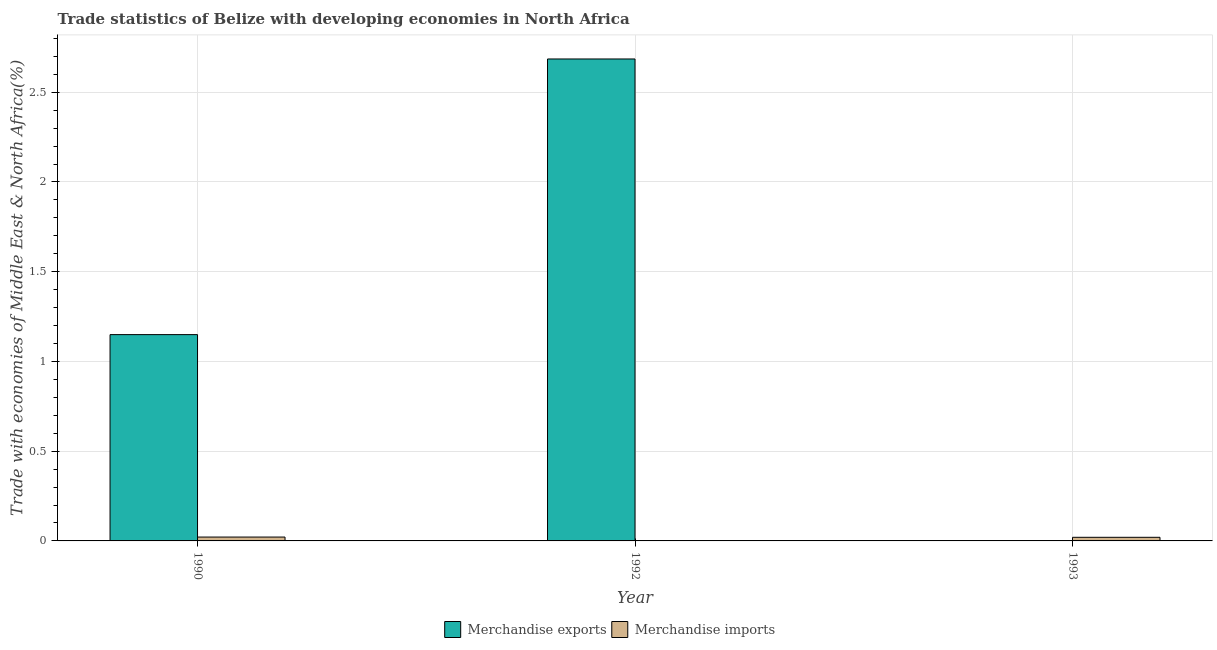How many different coloured bars are there?
Offer a very short reply. 2. How many groups of bars are there?
Offer a very short reply. 3. Are the number of bars per tick equal to the number of legend labels?
Offer a terse response. Yes. Are the number of bars on each tick of the X-axis equal?
Keep it short and to the point. Yes. How many bars are there on the 3rd tick from the right?
Your answer should be very brief. 2. What is the label of the 2nd group of bars from the left?
Your response must be concise. 1992. What is the merchandise exports in 1993?
Offer a terse response. 0. Across all years, what is the maximum merchandise exports?
Offer a terse response. 2.69. Across all years, what is the minimum merchandise imports?
Make the answer very short. 0. In which year was the merchandise imports minimum?
Your answer should be very brief. 1992. What is the total merchandise exports in the graph?
Offer a very short reply. 3.84. What is the difference between the merchandise imports in 1992 and that in 1993?
Ensure brevity in your answer.  -0.02. What is the difference between the merchandise exports in 1992 and the merchandise imports in 1993?
Offer a very short reply. 2.68. What is the average merchandise imports per year?
Make the answer very short. 0.01. In the year 1993, what is the difference between the merchandise exports and merchandise imports?
Your answer should be very brief. 0. What is the ratio of the merchandise exports in 1992 to that in 1993?
Offer a terse response. 7050.16. Is the difference between the merchandise exports in 1990 and 1993 greater than the difference between the merchandise imports in 1990 and 1993?
Your answer should be very brief. No. What is the difference between the highest and the second highest merchandise exports?
Make the answer very short. 1.54. What is the difference between the highest and the lowest merchandise imports?
Keep it short and to the point. 0.02. In how many years, is the merchandise imports greater than the average merchandise imports taken over all years?
Your answer should be very brief. 2. Is the sum of the merchandise exports in 1990 and 1992 greater than the maximum merchandise imports across all years?
Make the answer very short. Yes. How many bars are there?
Offer a terse response. 6. What is the difference between two consecutive major ticks on the Y-axis?
Provide a short and direct response. 0.5. Does the graph contain grids?
Provide a succinct answer. Yes. How many legend labels are there?
Keep it short and to the point. 2. How are the legend labels stacked?
Give a very brief answer. Horizontal. What is the title of the graph?
Your response must be concise. Trade statistics of Belize with developing economies in North Africa. Does "Goods" appear as one of the legend labels in the graph?
Keep it short and to the point. No. What is the label or title of the X-axis?
Provide a succinct answer. Year. What is the label or title of the Y-axis?
Provide a short and direct response. Trade with economies of Middle East & North Africa(%). What is the Trade with economies of Middle East & North Africa(%) in Merchandise exports in 1990?
Ensure brevity in your answer.  1.15. What is the Trade with economies of Middle East & North Africa(%) of Merchandise imports in 1990?
Make the answer very short. 0.02. What is the Trade with economies of Middle East & North Africa(%) in Merchandise exports in 1992?
Your answer should be compact. 2.69. What is the Trade with economies of Middle East & North Africa(%) of Merchandise imports in 1992?
Provide a succinct answer. 0. What is the Trade with economies of Middle East & North Africa(%) in Merchandise exports in 1993?
Your response must be concise. 0. What is the Trade with economies of Middle East & North Africa(%) of Merchandise imports in 1993?
Ensure brevity in your answer.  0.02. Across all years, what is the maximum Trade with economies of Middle East & North Africa(%) in Merchandise exports?
Give a very brief answer. 2.69. Across all years, what is the maximum Trade with economies of Middle East & North Africa(%) in Merchandise imports?
Make the answer very short. 0.02. Across all years, what is the minimum Trade with economies of Middle East & North Africa(%) of Merchandise exports?
Make the answer very short. 0. Across all years, what is the minimum Trade with economies of Middle East & North Africa(%) of Merchandise imports?
Give a very brief answer. 0. What is the total Trade with economies of Middle East & North Africa(%) of Merchandise exports in the graph?
Provide a succinct answer. 3.84. What is the total Trade with economies of Middle East & North Africa(%) of Merchandise imports in the graph?
Provide a succinct answer. 0.04. What is the difference between the Trade with economies of Middle East & North Africa(%) of Merchandise exports in 1990 and that in 1992?
Your answer should be compact. -1.54. What is the difference between the Trade with economies of Middle East & North Africa(%) of Merchandise imports in 1990 and that in 1992?
Offer a terse response. 0.02. What is the difference between the Trade with economies of Middle East & North Africa(%) in Merchandise exports in 1990 and that in 1993?
Provide a succinct answer. 1.15. What is the difference between the Trade with economies of Middle East & North Africa(%) in Merchandise imports in 1990 and that in 1993?
Offer a very short reply. 0. What is the difference between the Trade with economies of Middle East & North Africa(%) in Merchandise exports in 1992 and that in 1993?
Give a very brief answer. 2.68. What is the difference between the Trade with economies of Middle East & North Africa(%) in Merchandise imports in 1992 and that in 1993?
Offer a terse response. -0.02. What is the difference between the Trade with economies of Middle East & North Africa(%) in Merchandise exports in 1990 and the Trade with economies of Middle East & North Africa(%) in Merchandise imports in 1992?
Provide a succinct answer. 1.15. What is the difference between the Trade with economies of Middle East & North Africa(%) in Merchandise exports in 1990 and the Trade with economies of Middle East & North Africa(%) in Merchandise imports in 1993?
Offer a very short reply. 1.13. What is the difference between the Trade with economies of Middle East & North Africa(%) of Merchandise exports in 1992 and the Trade with economies of Middle East & North Africa(%) of Merchandise imports in 1993?
Make the answer very short. 2.67. What is the average Trade with economies of Middle East & North Africa(%) of Merchandise exports per year?
Offer a terse response. 1.28. What is the average Trade with economies of Middle East & North Africa(%) in Merchandise imports per year?
Your answer should be very brief. 0.01. In the year 1990, what is the difference between the Trade with economies of Middle East & North Africa(%) of Merchandise exports and Trade with economies of Middle East & North Africa(%) of Merchandise imports?
Ensure brevity in your answer.  1.13. In the year 1992, what is the difference between the Trade with economies of Middle East & North Africa(%) in Merchandise exports and Trade with economies of Middle East & North Africa(%) in Merchandise imports?
Provide a succinct answer. 2.69. In the year 1993, what is the difference between the Trade with economies of Middle East & North Africa(%) in Merchandise exports and Trade with economies of Middle East & North Africa(%) in Merchandise imports?
Keep it short and to the point. -0.02. What is the ratio of the Trade with economies of Middle East & North Africa(%) in Merchandise exports in 1990 to that in 1992?
Offer a very short reply. 0.43. What is the ratio of the Trade with economies of Middle East & North Africa(%) in Merchandise imports in 1990 to that in 1992?
Ensure brevity in your answer.  134.55. What is the ratio of the Trade with economies of Middle East & North Africa(%) in Merchandise exports in 1990 to that in 1993?
Offer a very short reply. 3017.86. What is the ratio of the Trade with economies of Middle East & North Africa(%) of Merchandise imports in 1990 to that in 1993?
Provide a succinct answer. 1.07. What is the ratio of the Trade with economies of Middle East & North Africa(%) of Merchandise exports in 1992 to that in 1993?
Make the answer very short. 7050.16. What is the ratio of the Trade with economies of Middle East & North Africa(%) in Merchandise imports in 1992 to that in 1993?
Make the answer very short. 0.01. What is the difference between the highest and the second highest Trade with economies of Middle East & North Africa(%) in Merchandise exports?
Offer a very short reply. 1.54. What is the difference between the highest and the second highest Trade with economies of Middle East & North Africa(%) in Merchandise imports?
Your response must be concise. 0. What is the difference between the highest and the lowest Trade with economies of Middle East & North Africa(%) of Merchandise exports?
Give a very brief answer. 2.68. What is the difference between the highest and the lowest Trade with economies of Middle East & North Africa(%) in Merchandise imports?
Offer a very short reply. 0.02. 